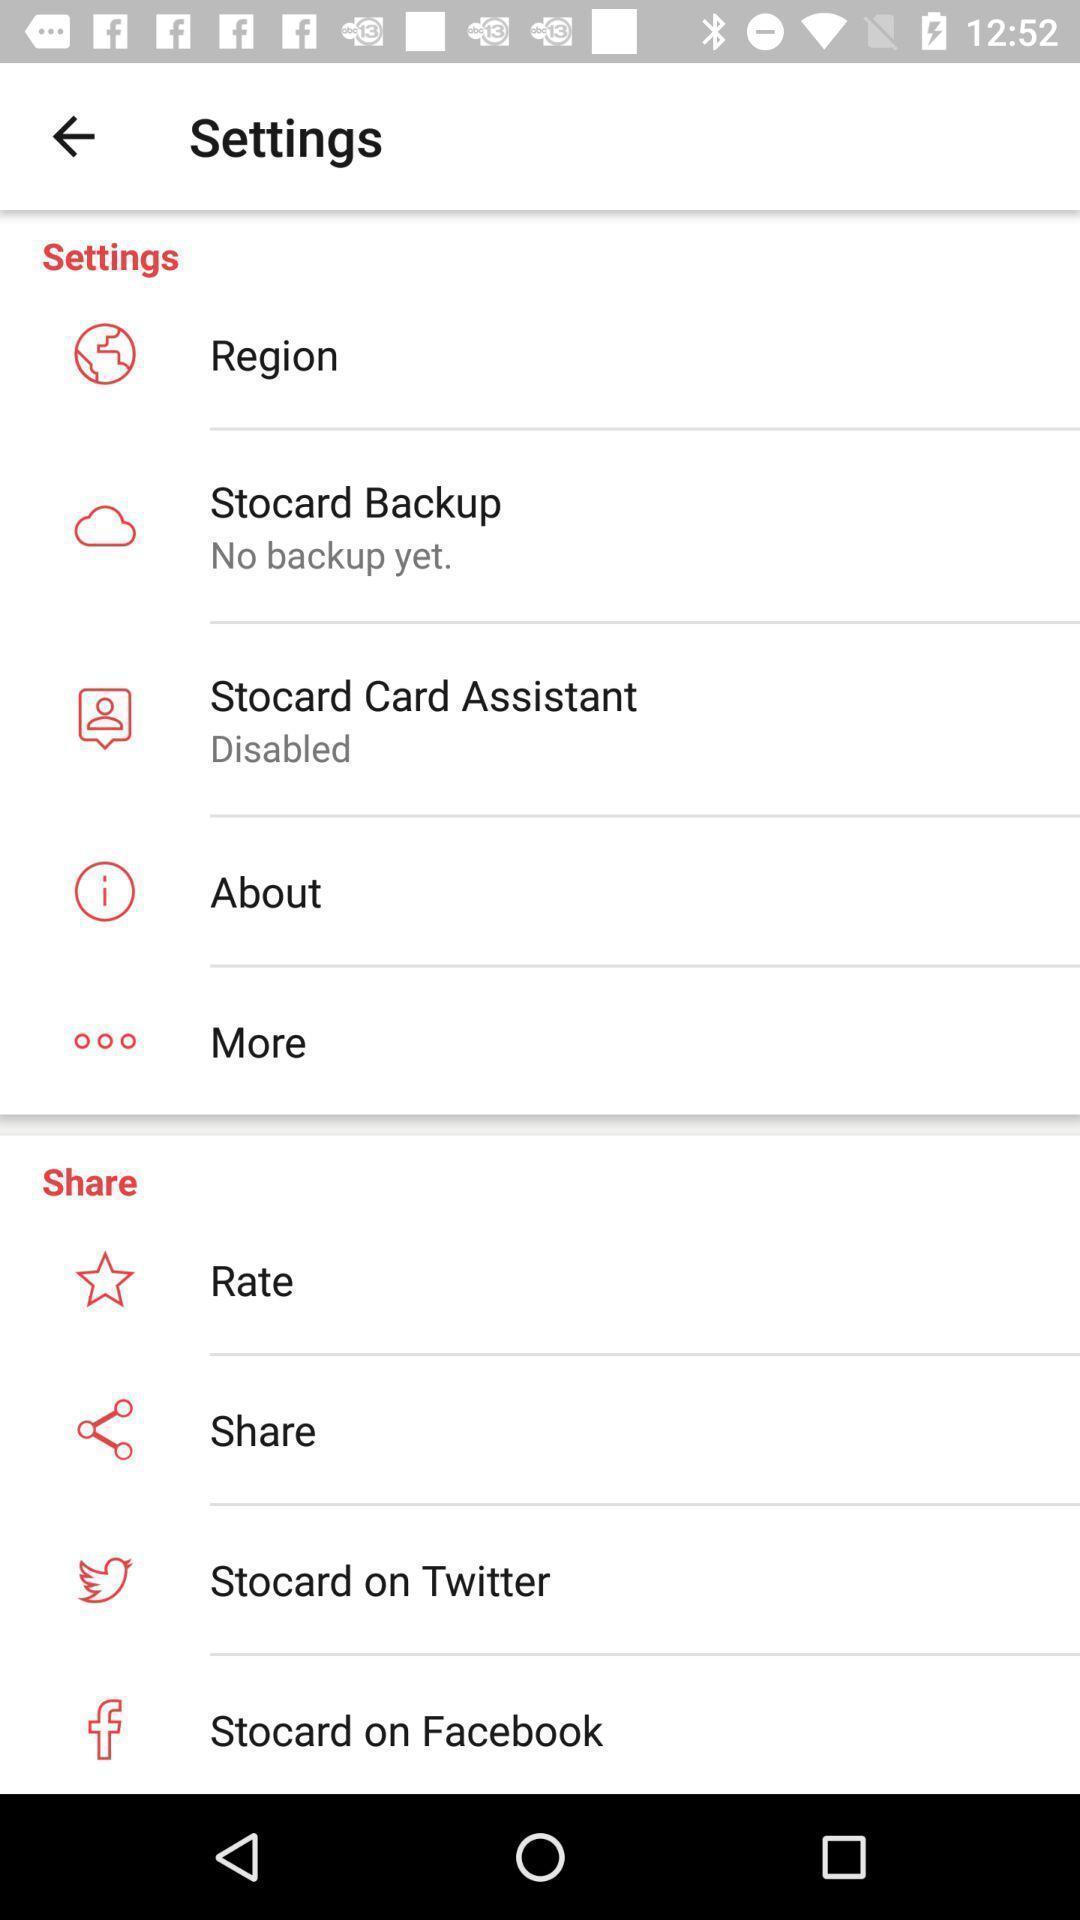Describe this image in words. Settings page for the coupons card app. 